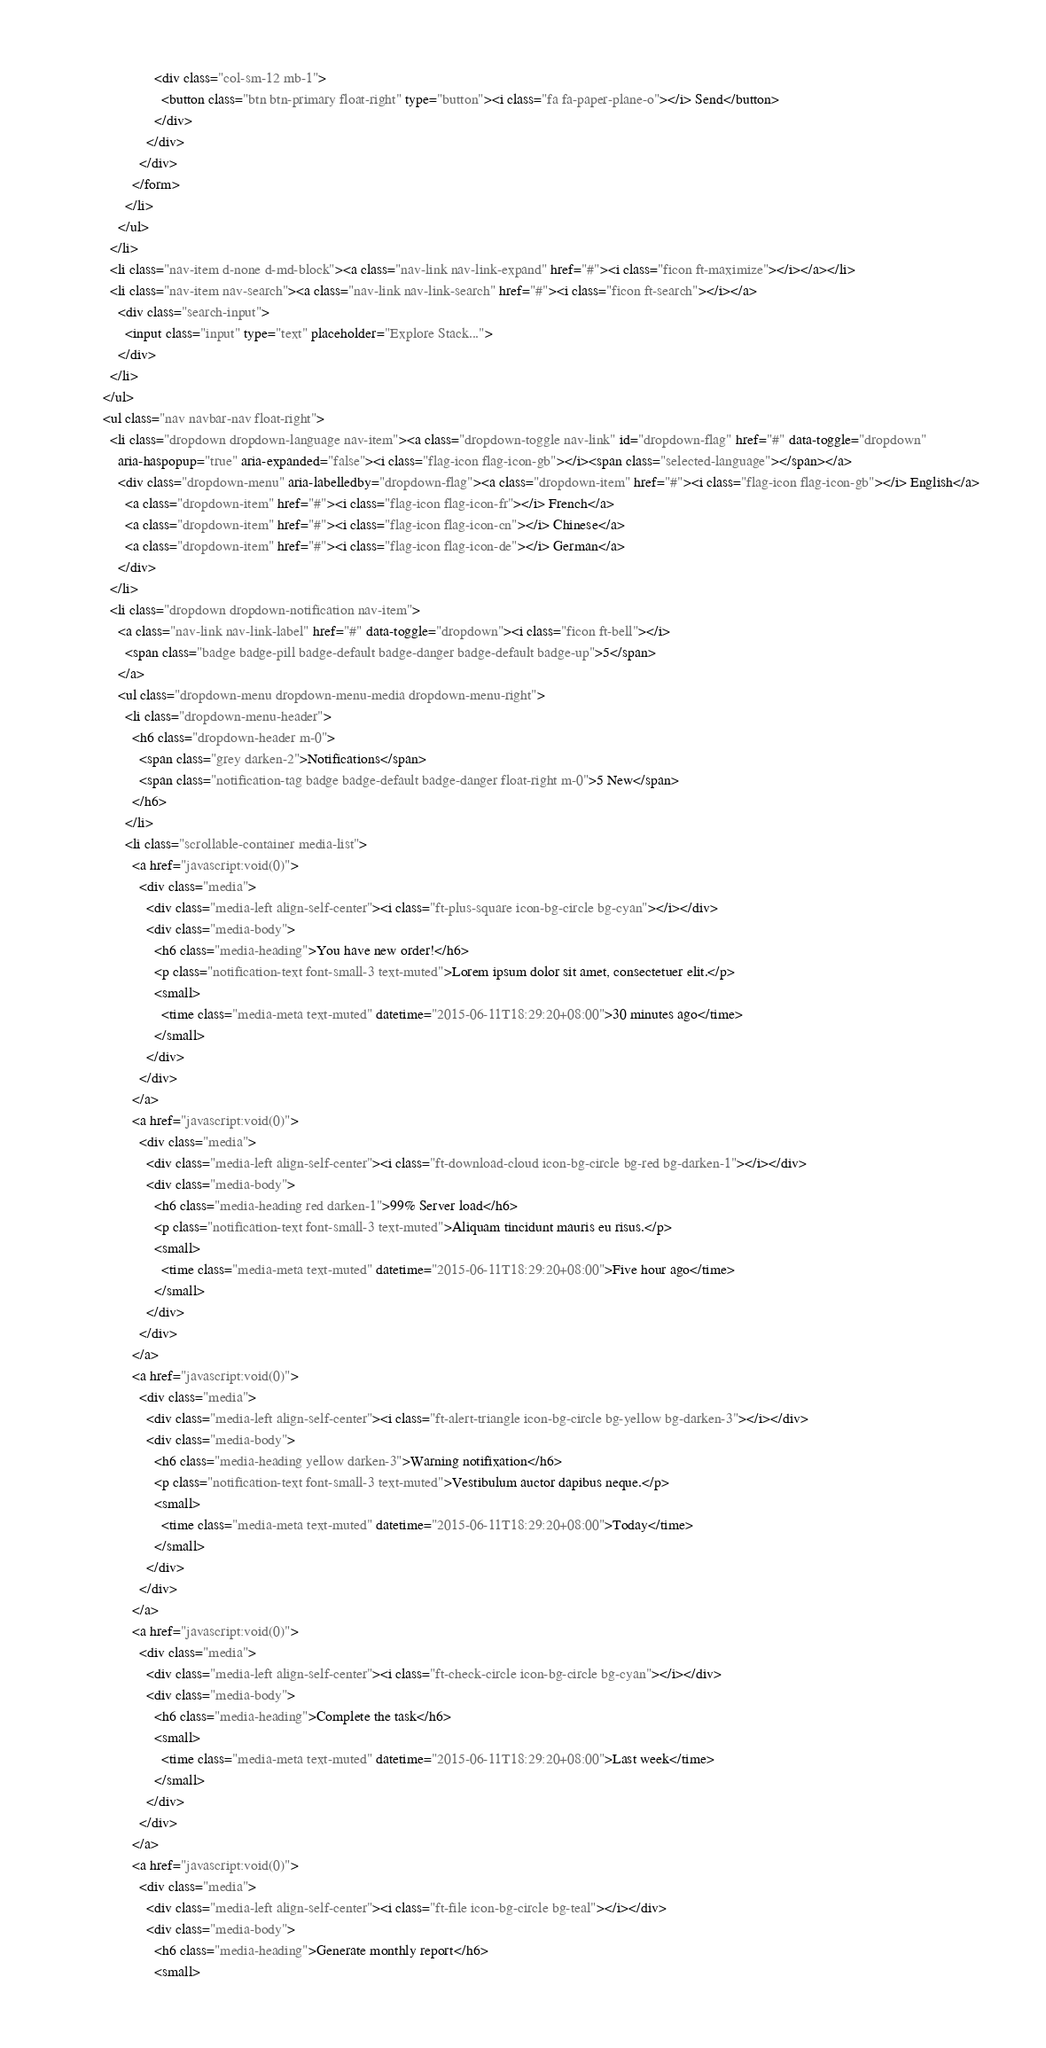Convert code to text. <code><loc_0><loc_0><loc_500><loc_500><_HTML_>                        <div class="col-sm-12 mb-1">
                          <button class="btn btn-primary float-right" type="button"><i class="fa fa-paper-plane-o"></i> Send</button>
                        </div>
                      </div>
                    </div>
                  </form>
                </li>
              </ul>
            </li>
            <li class="nav-item d-none d-md-block"><a class="nav-link nav-link-expand" href="#"><i class="ficon ft-maximize"></i></a></li>
            <li class="nav-item nav-search"><a class="nav-link nav-link-search" href="#"><i class="ficon ft-search"></i></a>
              <div class="search-input">
                <input class="input" type="text" placeholder="Explore Stack...">
              </div>
            </li>
          </ul>
          <ul class="nav navbar-nav float-right">
            <li class="dropdown dropdown-language nav-item"><a class="dropdown-toggle nav-link" id="dropdown-flag" href="#" data-toggle="dropdown"
              aria-haspopup="true" aria-expanded="false"><i class="flag-icon flag-icon-gb"></i><span class="selected-language"></span></a>
              <div class="dropdown-menu" aria-labelledby="dropdown-flag"><a class="dropdown-item" href="#"><i class="flag-icon flag-icon-gb"></i> English</a>
                <a class="dropdown-item" href="#"><i class="flag-icon flag-icon-fr"></i> French</a>
                <a class="dropdown-item" href="#"><i class="flag-icon flag-icon-cn"></i> Chinese</a>
                <a class="dropdown-item" href="#"><i class="flag-icon flag-icon-de"></i> German</a>
              </div>
            </li>
            <li class="dropdown dropdown-notification nav-item">
              <a class="nav-link nav-link-label" href="#" data-toggle="dropdown"><i class="ficon ft-bell"></i>
                <span class="badge badge-pill badge-default badge-danger badge-default badge-up">5</span>
              </a>
              <ul class="dropdown-menu dropdown-menu-media dropdown-menu-right">
                <li class="dropdown-menu-header">
                  <h6 class="dropdown-header m-0">
                    <span class="grey darken-2">Notifications</span>
                    <span class="notification-tag badge badge-default badge-danger float-right m-0">5 New</span>
                  </h6>
                </li>
                <li class="scrollable-container media-list">
                  <a href="javascript:void(0)">
                    <div class="media">
                      <div class="media-left align-self-center"><i class="ft-plus-square icon-bg-circle bg-cyan"></i></div>
                      <div class="media-body">
                        <h6 class="media-heading">You have new order!</h6>
                        <p class="notification-text font-small-3 text-muted">Lorem ipsum dolor sit amet, consectetuer elit.</p>
                        <small>
                          <time class="media-meta text-muted" datetime="2015-06-11T18:29:20+08:00">30 minutes ago</time>
                        </small>
                      </div>
                    </div>
                  </a>
                  <a href="javascript:void(0)">
                    <div class="media">
                      <div class="media-left align-self-center"><i class="ft-download-cloud icon-bg-circle bg-red bg-darken-1"></i></div>
                      <div class="media-body">
                        <h6 class="media-heading red darken-1">99% Server load</h6>
                        <p class="notification-text font-small-3 text-muted">Aliquam tincidunt mauris eu risus.</p>
                        <small>
                          <time class="media-meta text-muted" datetime="2015-06-11T18:29:20+08:00">Five hour ago</time>
                        </small>
                      </div>
                    </div>
                  </a>
                  <a href="javascript:void(0)">
                    <div class="media">
                      <div class="media-left align-self-center"><i class="ft-alert-triangle icon-bg-circle bg-yellow bg-darken-3"></i></div>
                      <div class="media-body">
                        <h6 class="media-heading yellow darken-3">Warning notifixation</h6>
                        <p class="notification-text font-small-3 text-muted">Vestibulum auctor dapibus neque.</p>
                        <small>
                          <time class="media-meta text-muted" datetime="2015-06-11T18:29:20+08:00">Today</time>
                        </small>
                      </div>
                    </div>
                  </a>
                  <a href="javascript:void(0)">
                    <div class="media">
                      <div class="media-left align-self-center"><i class="ft-check-circle icon-bg-circle bg-cyan"></i></div>
                      <div class="media-body">
                        <h6 class="media-heading">Complete the task</h6>
                        <small>
                          <time class="media-meta text-muted" datetime="2015-06-11T18:29:20+08:00">Last week</time>
                        </small>
                      </div>
                    </div>
                  </a>
                  <a href="javascript:void(0)">
                    <div class="media">
                      <div class="media-left align-self-center"><i class="ft-file icon-bg-circle bg-teal"></i></div>
                      <div class="media-body">
                        <h6 class="media-heading">Generate monthly report</h6>
                        <small></code> 